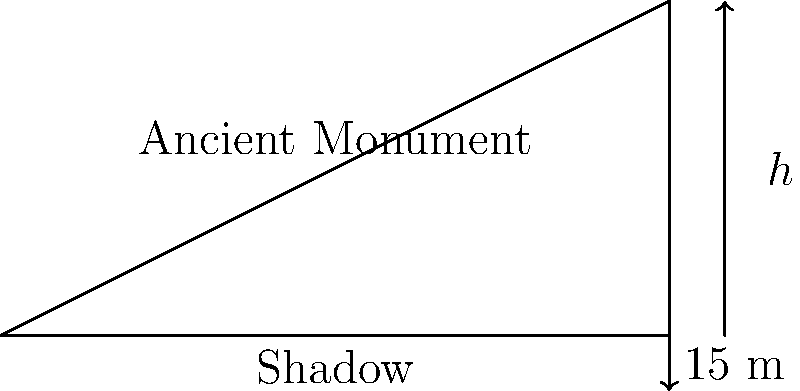An archaeologist is studying an ancient monument and wants to calculate its height without damaging it. At a certain time of day, when the sun's angle of elevation is 30°, the monument casts a shadow 15 meters long. Using trigonometric ratios, calculate the height of the monument to the nearest tenth of a meter. Let's approach this step-by-step:

1) First, we need to identify the trigonometric ratio that relates the height of the monument to its shadow length.

2) In this case, we have:
   - The adjacent side (shadow length) = 15 m
   - The angle of elevation = 30°
   - We need to find the opposite side (height of the monument)

3) The trigonometric ratio that relates the opposite side to the adjacent side is tangent (tan).

4) So, we can set up the equation:
   $$\tan(30°) = \frac{\text{height}}{\text{shadow length}}$$

5) Plugging in the known values:
   $$\tan(30°) = \frac{h}{15}$$

6) To solve for h, multiply both sides by 15:
   $$15 \cdot \tan(30°) = h$$

7) Now, we need to calculate this:
   $$h = 15 \cdot \tan(30°)$$

8) $\tan(30°) = \frac{1}{\sqrt{3}} \approx 0.577$

9) So, $h = 15 \cdot 0.577 \approx 8.655$ meters

10) Rounding to the nearest tenth:
    $h \approx 8.7$ meters

Thus, the height of the ancient monument is approximately 8.7 meters.
Answer: 8.7 meters 